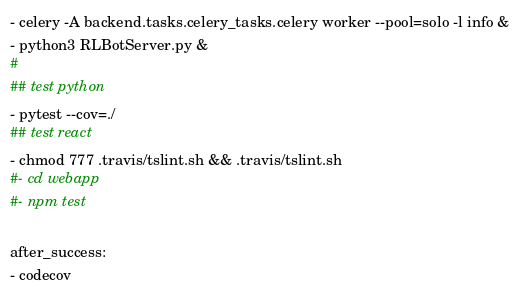Convert code to text. <code><loc_0><loc_0><loc_500><loc_500><_YAML_>- celery -A backend.tasks.celery_tasks.celery worker --pool=solo -l info &
- python3 RLBotServer.py &
#
## test python
- pytest --cov=./
## test react
- chmod 777 .travis/tslint.sh && .travis/tslint.sh
#- cd webapp
#- npm test

after_success:
- codecov
</code> 